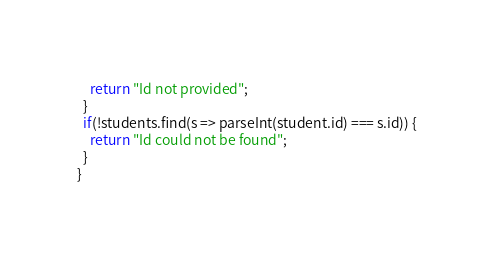Convert code to text. <code><loc_0><loc_0><loc_500><loc_500><_JavaScript_>    return "Id not provided";
  }
  if(!students.find(s => parseInt(student.id) === s.id)) {
    return "Id could not be found";
  }
}
</code> 